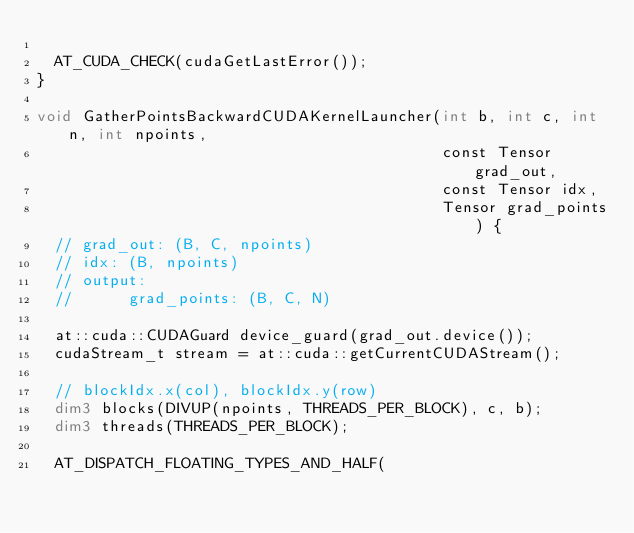<code> <loc_0><loc_0><loc_500><loc_500><_Cuda_>
  AT_CUDA_CHECK(cudaGetLastError());
}

void GatherPointsBackwardCUDAKernelLauncher(int b, int c, int n, int npoints,
                                            const Tensor grad_out,
                                            const Tensor idx,
                                            Tensor grad_points) {
  // grad_out: (B, C, npoints)
  // idx: (B, npoints)
  // output:
  //      grad_points: (B, C, N)

  at::cuda::CUDAGuard device_guard(grad_out.device());
  cudaStream_t stream = at::cuda::getCurrentCUDAStream();

  // blockIdx.x(col), blockIdx.y(row)
  dim3 blocks(DIVUP(npoints, THREADS_PER_BLOCK), c, b);
  dim3 threads(THREADS_PER_BLOCK);

  AT_DISPATCH_FLOATING_TYPES_AND_HALF(</code> 